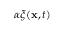Convert formula to latex. <formula><loc_0><loc_0><loc_500><loc_500>\alpha \xi ( { x } , t )</formula> 